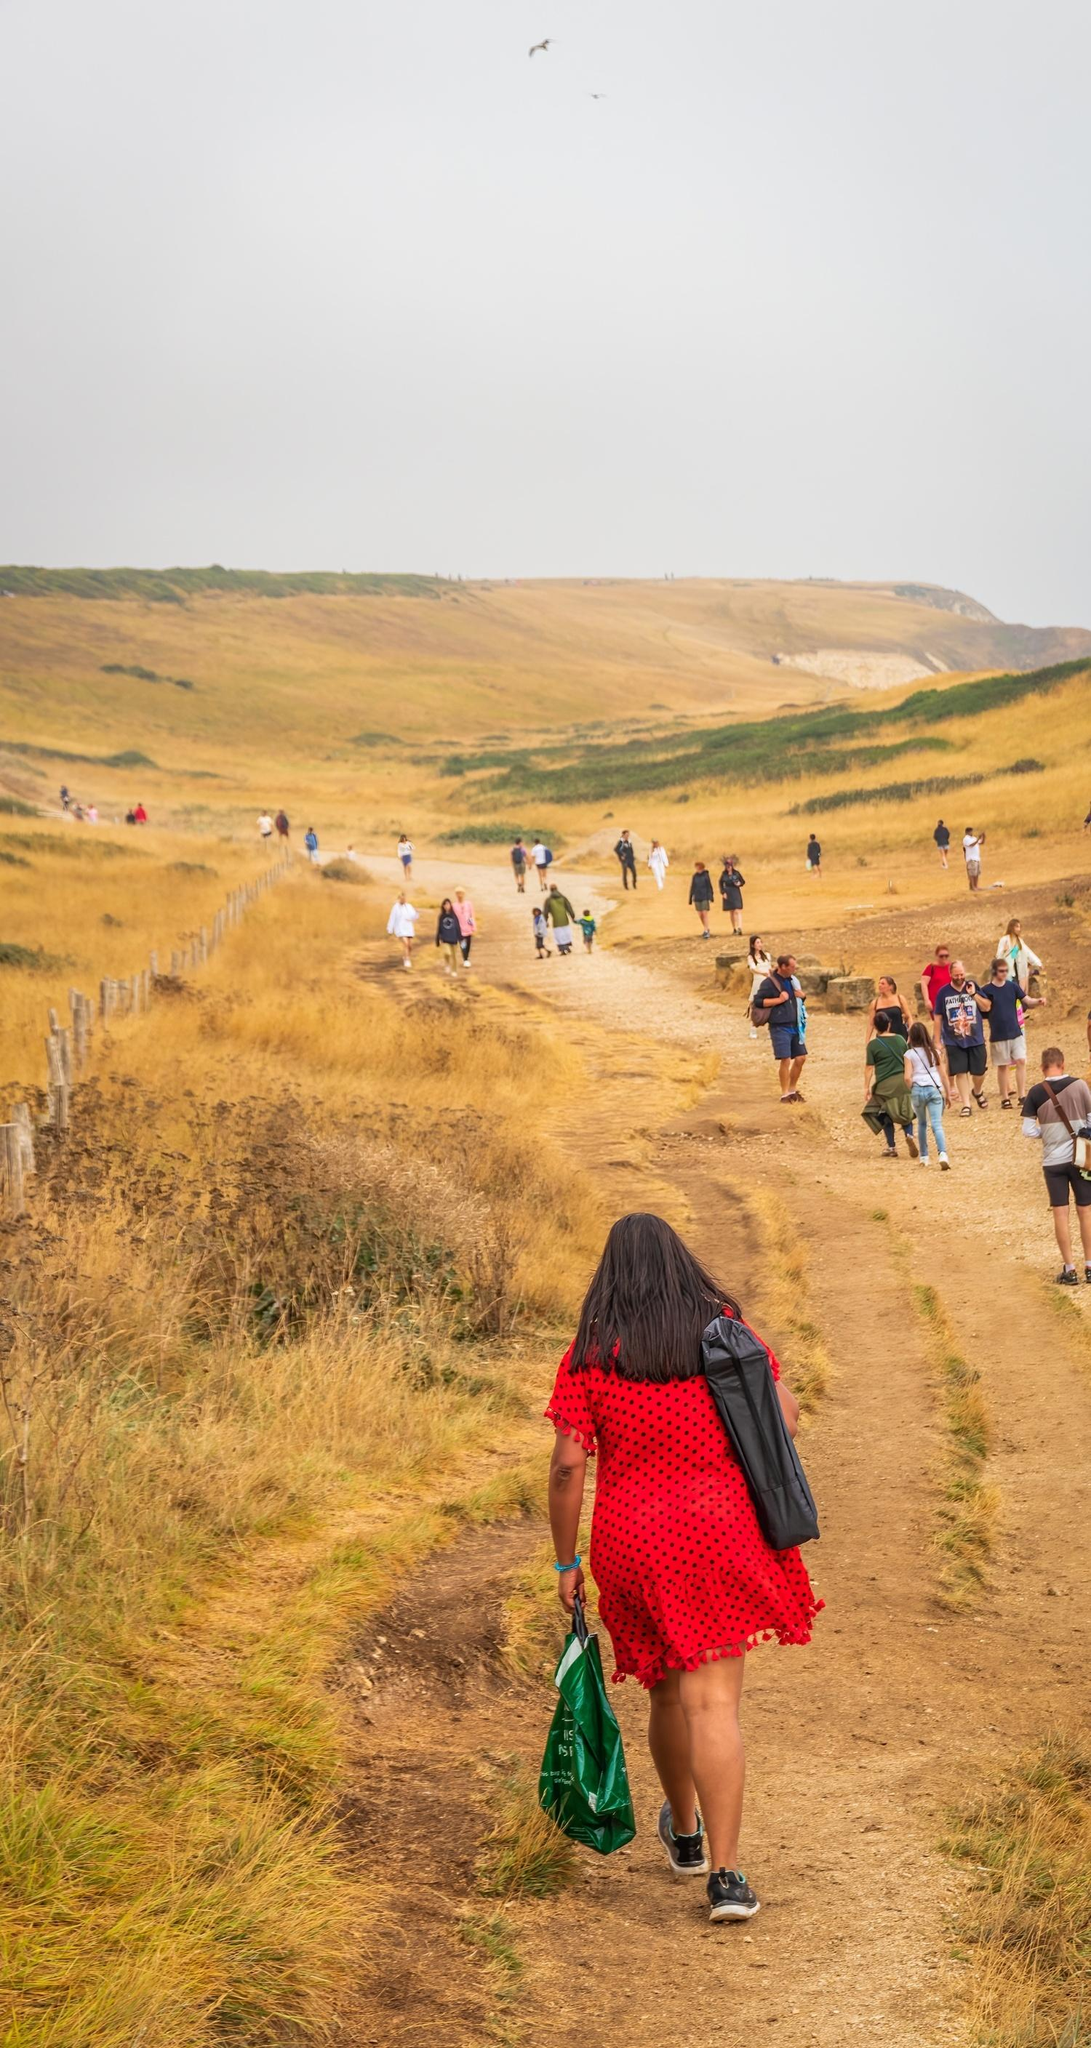Describe the mood conveyed by the image. The mood conveyed by the image is one of tranquility and companionship. The group of people walking together through the serene countryside with gentle hills and a cloudy sky evokes a sense of peacefulness and relaxation. Their leisurely pace and casual attire indicate a day of enjoyment and camaraderie, amplifying the feel of a joyful escape from daily routines. 